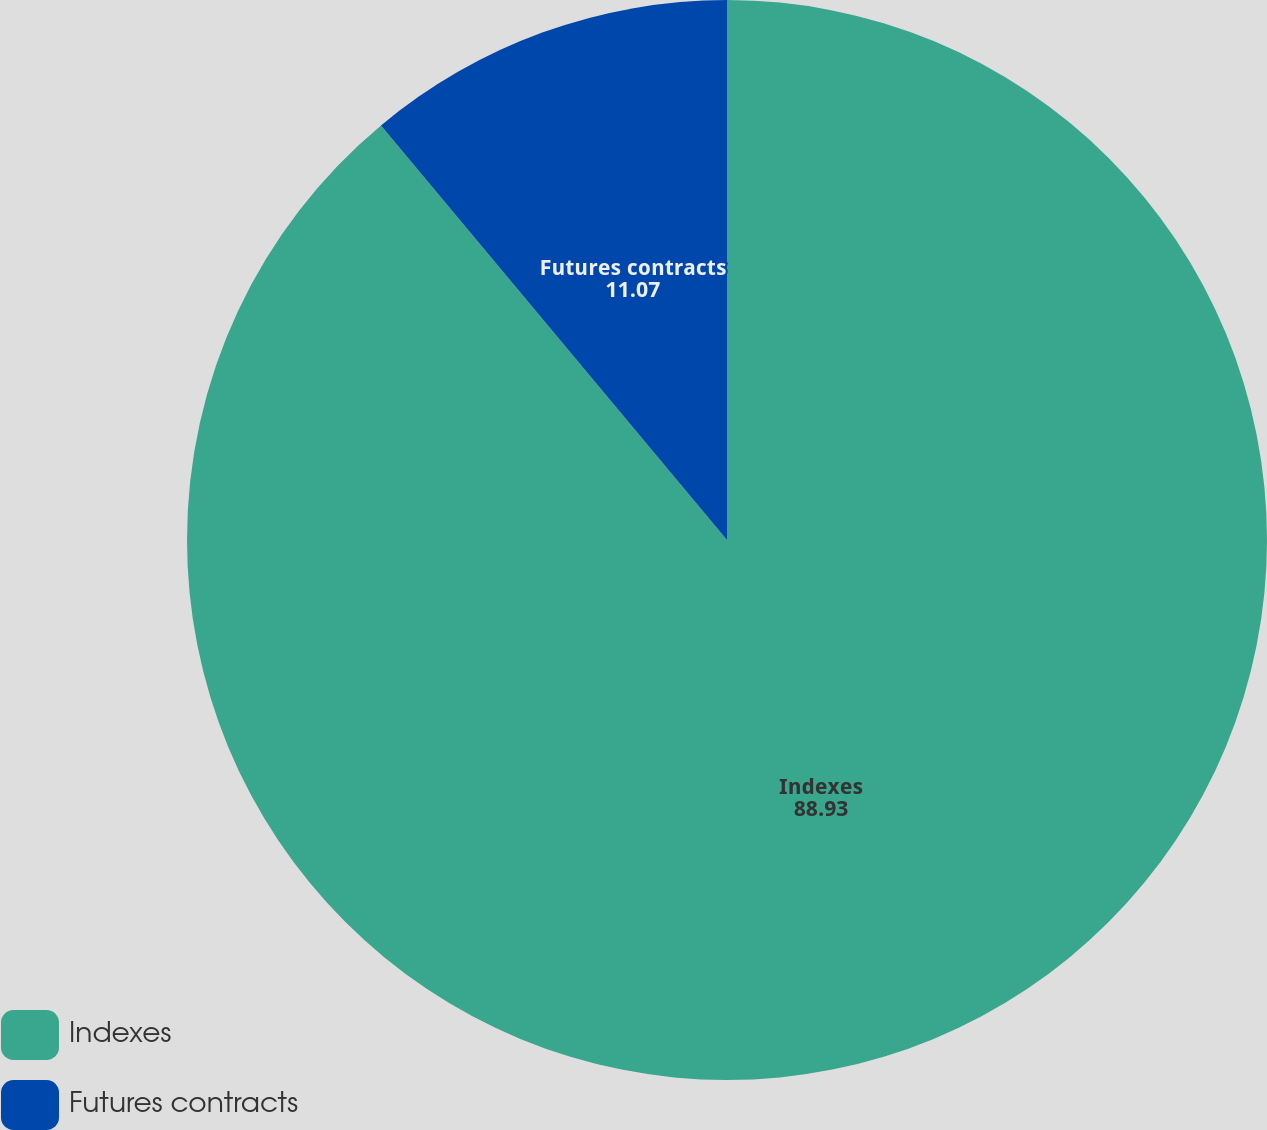<chart> <loc_0><loc_0><loc_500><loc_500><pie_chart><fcel>Indexes<fcel>Futures contracts<nl><fcel>88.93%<fcel>11.07%<nl></chart> 